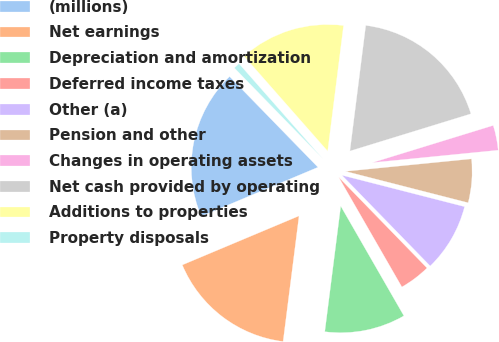<chart> <loc_0><loc_0><loc_500><loc_500><pie_chart><fcel>(millions)<fcel>Net earnings<fcel>Depreciation and amortization<fcel>Deferred income taxes<fcel>Other (a)<fcel>Pension and other<fcel>Changes in operating assets<fcel>Net cash provided by operating<fcel>Additions to properties<fcel>Property disposals<nl><fcel>19.04%<fcel>16.66%<fcel>10.32%<fcel>3.97%<fcel>8.73%<fcel>5.56%<fcel>3.18%<fcel>18.25%<fcel>13.49%<fcel>0.8%<nl></chart> 